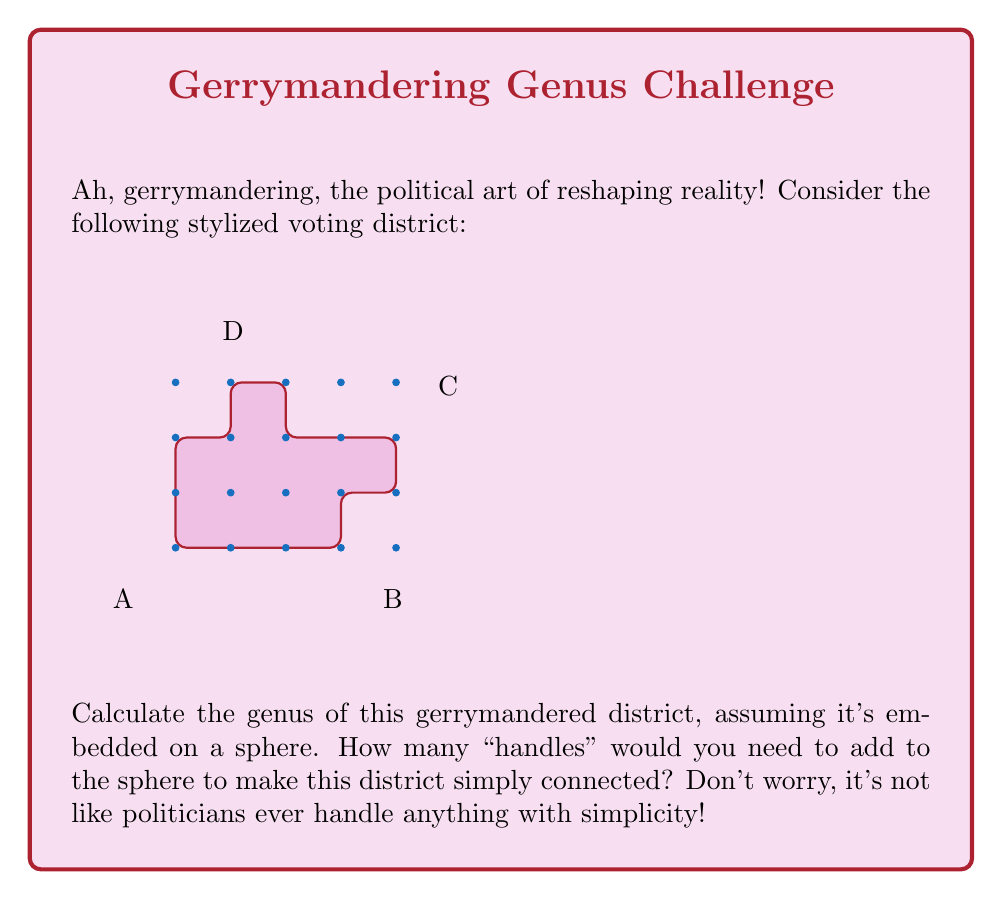Show me your answer to this math problem. Let's approach this with the subtlety of a political campaign promise:

1) First, we need to calculate the Euler characteristic ($\chi$) of the district:
   
   $\chi = V - E + F$
   
   Where V = number of vertices, E = number of edges, F = number of faces

2) Counting from the diagram:
   V = 15 (all dots on the grid)
   E = 18 (count the edges)
   F = 2 (the district itself and the outside region)

3) Plugging into the formula:
   $\chi = 15 - 18 + 2 = -1$

4) For a sphere, $\chi = 2$. The difference between our shape and a sphere is:
   $2 - (-1) = 3$

5) The genus (g) of a surface is related to $\chi$ by the formula:
   $\chi = 2 - 2g$

6) Solving for g:
   $-1 = 2 - 2g$
   $2g = 3$
   $g = \frac{3}{2}$

7) Since genus must be a whole number, we round up to 2.

Therefore, we need to add 2 handles to the sphere to make this district simply connected.
Answer: 2 handles 